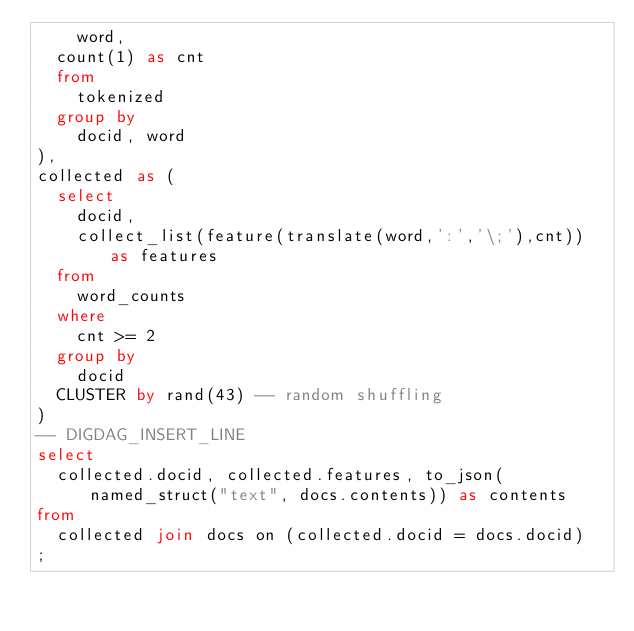Convert code to text. <code><loc_0><loc_0><loc_500><loc_500><_SQL_>    word,
	count(1) as cnt
  from 
    tokenized
  group by
    docid, word
),
collected as (
  select 
    docid,
    collect_list(feature(translate(word,':','\;'),cnt)) as features
  from 
    word_counts
  where
    cnt >= 2
  group by 
    docid
  CLUSTER by rand(43) -- random shuffling
)
-- DIGDAG_INSERT_LINE
select
  collected.docid, collected.features, to_json(named_struct("text", docs.contents)) as contents
from
  collected join docs on (collected.docid = docs.docid)
;
</code> 